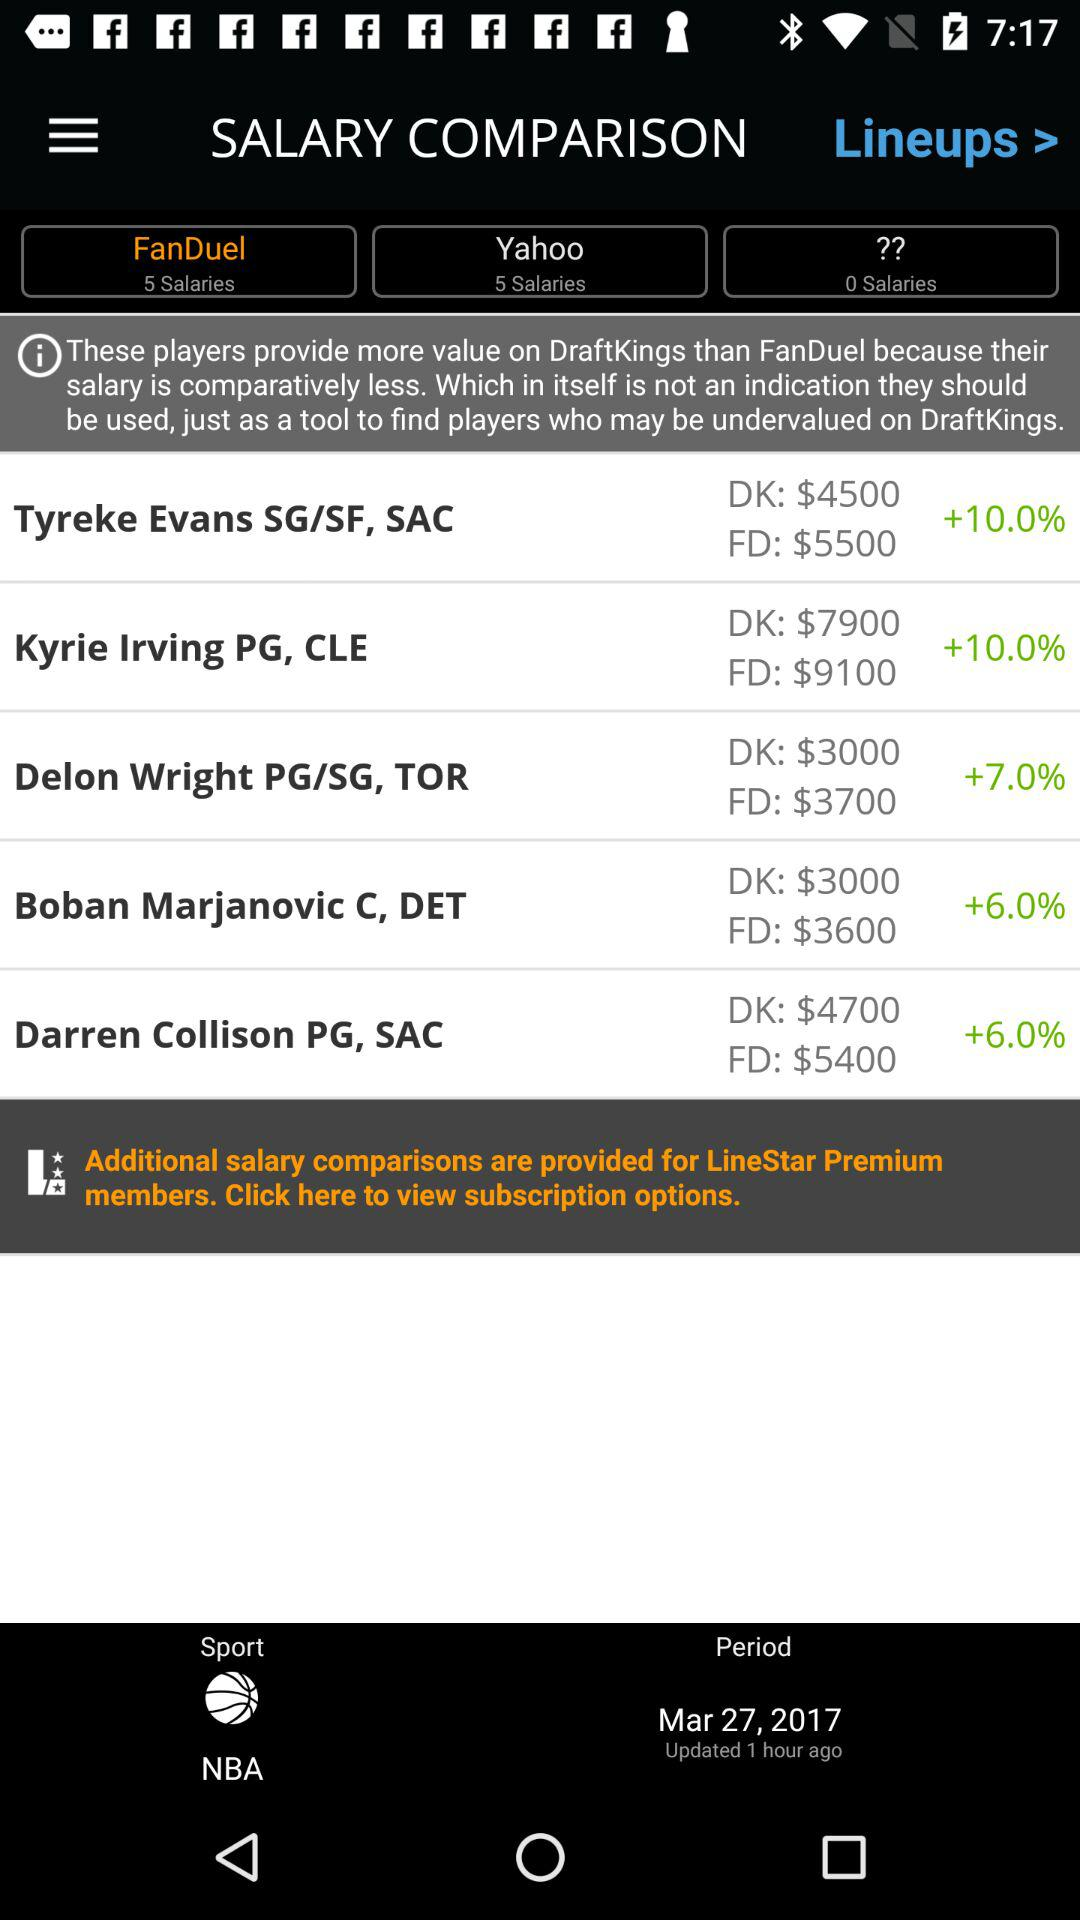How many hours ago was the last update? The last update was 1 hour ago. 